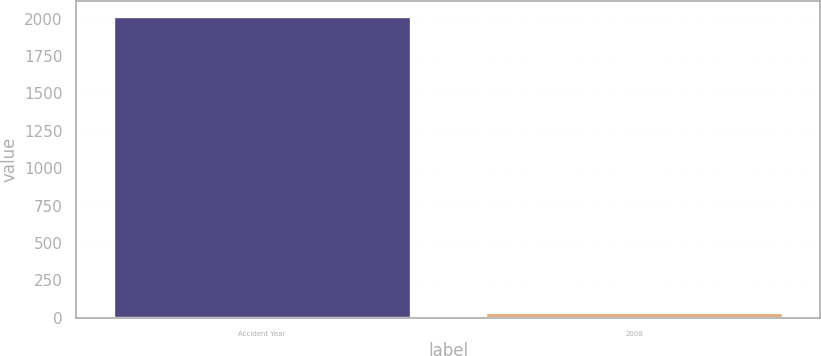Convert chart to OTSL. <chart><loc_0><loc_0><loc_500><loc_500><bar_chart><fcel>Accident Year<fcel>2008<nl><fcel>2016<fcel>39<nl></chart> 